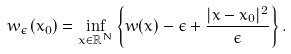<formula> <loc_0><loc_0><loc_500><loc_500>w _ { \epsilon } ( x _ { 0 } ) = \inf _ { x \in \mathbb { R } ^ { N } } \left \{ w ( x ) - \epsilon + \frac { | x - x _ { 0 } | ^ { 2 } } { \epsilon } \right \} .</formula> 